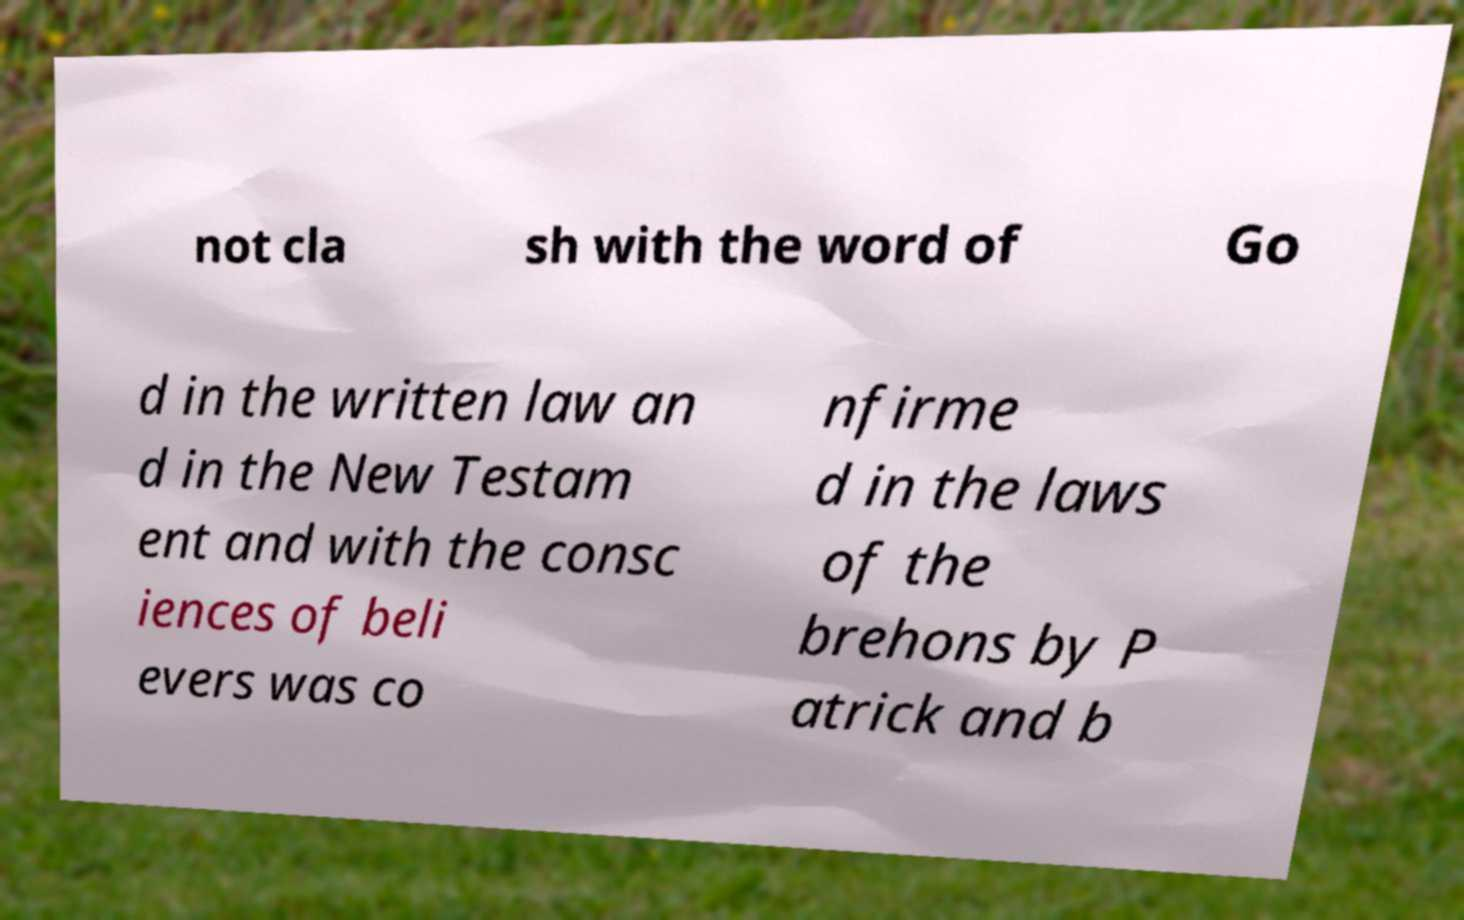Can you accurately transcribe the text from the provided image for me? not cla sh with the word of Go d in the written law an d in the New Testam ent and with the consc iences of beli evers was co nfirme d in the laws of the brehons by P atrick and b 